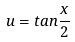<formula> <loc_0><loc_0><loc_500><loc_500>u = t a n \frac { x } { 2 }</formula> 